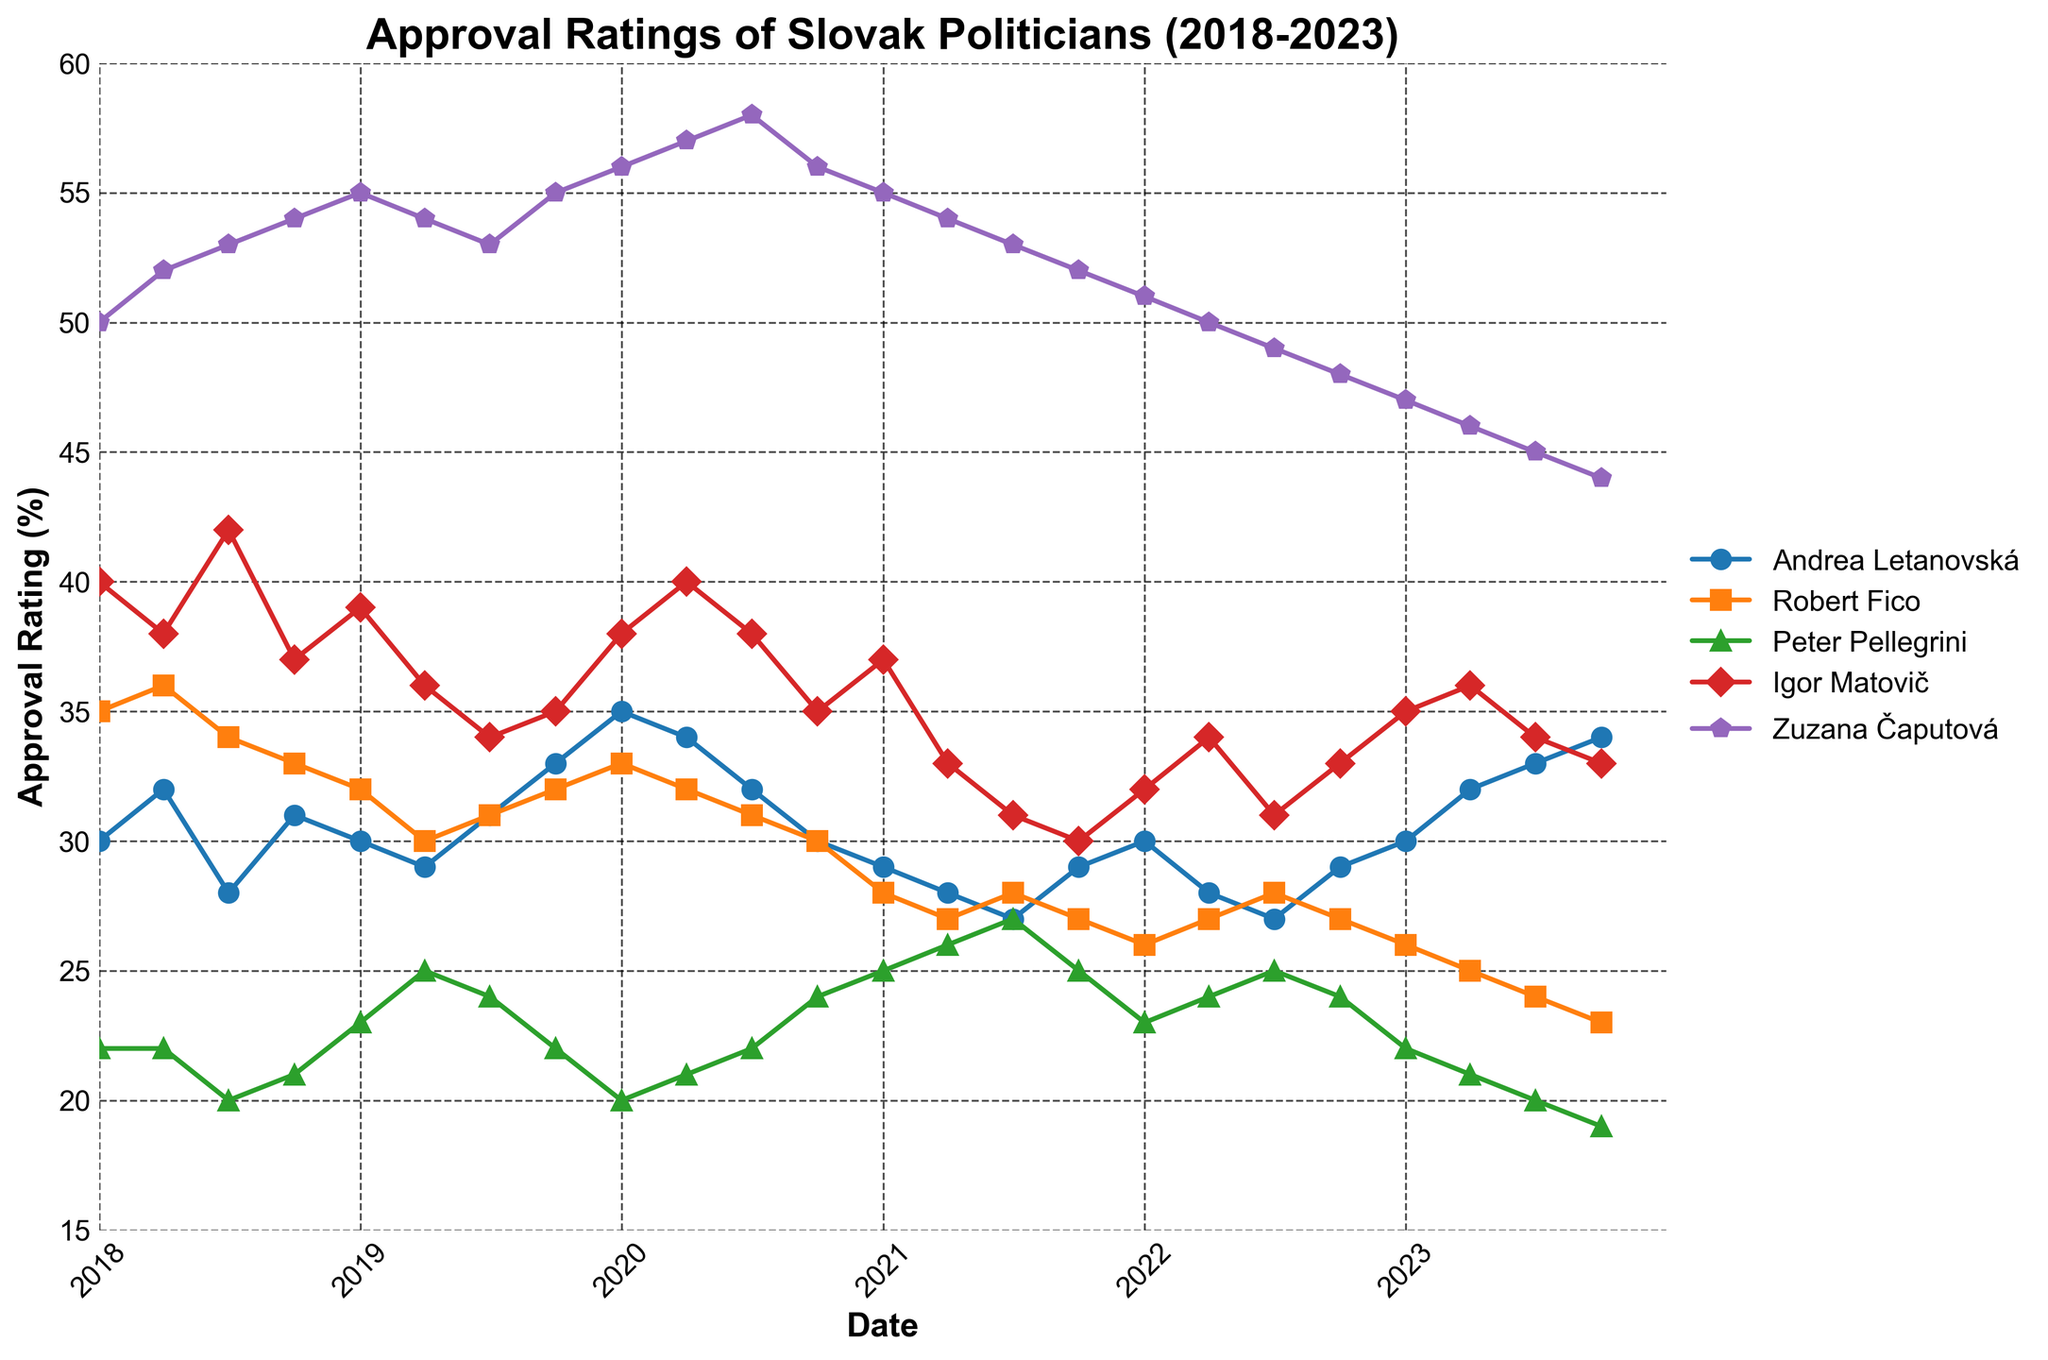What is the title of the time series plot? The title is located at the top of the plot, and it describes the subject of the data presented. In this case, it reads "Approval Ratings of Slovak Politicians (2018-2023)."
Answer: Approval Ratings of Slovak Politicians (2018-2023) How many politicians' approval ratings are shown on the plot? Each politician's name is indicated in the legend on the right side of the plot. There are five politicians listed.
Answer: 5 Which politician had the highest approval rating in 2018? To find this, check the plots for each politician in 2018. Zuzana Čaputová consistently had the highest ratings above others throughout 2018.
Answer: Zuzana Čaputová What was Andrea Letanovská's approval rating in July 2023? Locate the data point for Andrea Letanovská in July 2023 along the x-axis. The y-axis value at the intersection is 33.
Answer: 33 How did Andrea Letanovská’s approval rating change from January 2018 to October 2023? Find the starting point for Andrea Letanovská in January 2018, which is 30, and the ending point in October 2023, which is 34. Compute the difference, which is 34 - 30.
Answer: Increased by 4 Who had a lower approval rating in October 2023, Robert Fico or Peter Pellegrini? Compare the ratings of both politicians in October 2023. Robert Fico had 23, while Peter Pellegrini had 19.
Answer: Peter Pellegrini What was the trend in Igor Matovič's approval rating from 2018 to 2023? Looking at the points for Igor Matovič over the timeline from 2018 to 2023, his approval rating starts high and generally declines over time.
Answer: Declining Who showed an increase in approval rating from October 2022 to October 2023? Compare the approval ratings for each politician between these two dates. Andrea Letanovská increased from 29 to 34, and Igor Matovič increased from 33 to 36. Andrea is the notable one with a significant increase.
Answer: Andrea Letanovská Between April 2020 and April 2021, which politician had a steeper decline in approval rating, Andrea Letanovská or Zuzana Čaputová? Evaluate the slope of the line for both politicians between April 2020 and April 2021. Andrea Letanovská decreases from 34 to 28 (6 points), and Zuzana Čaputová decreases from 57 to 54 (3 points). Andrea’s decline is steeper.
Answer: Andrea Letanovská 